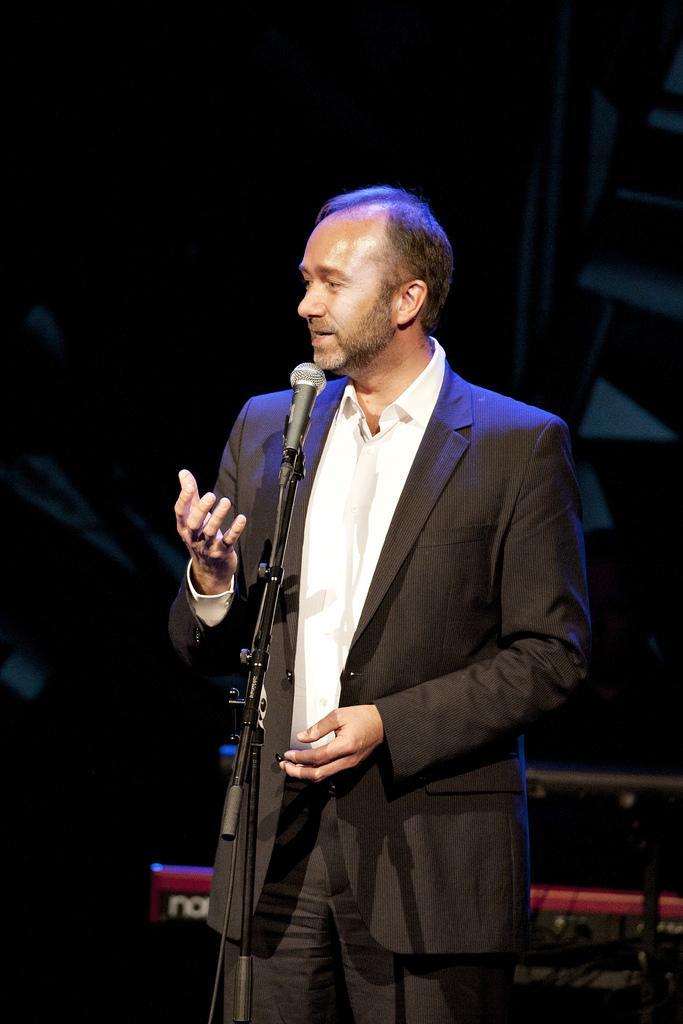Could you give a brief overview of what you see in this image? In this image we can see a person wearing coat is standing on the ground. In the foreground we can see a microphone placed on a stand. In the background, we can see some musical instruments. 